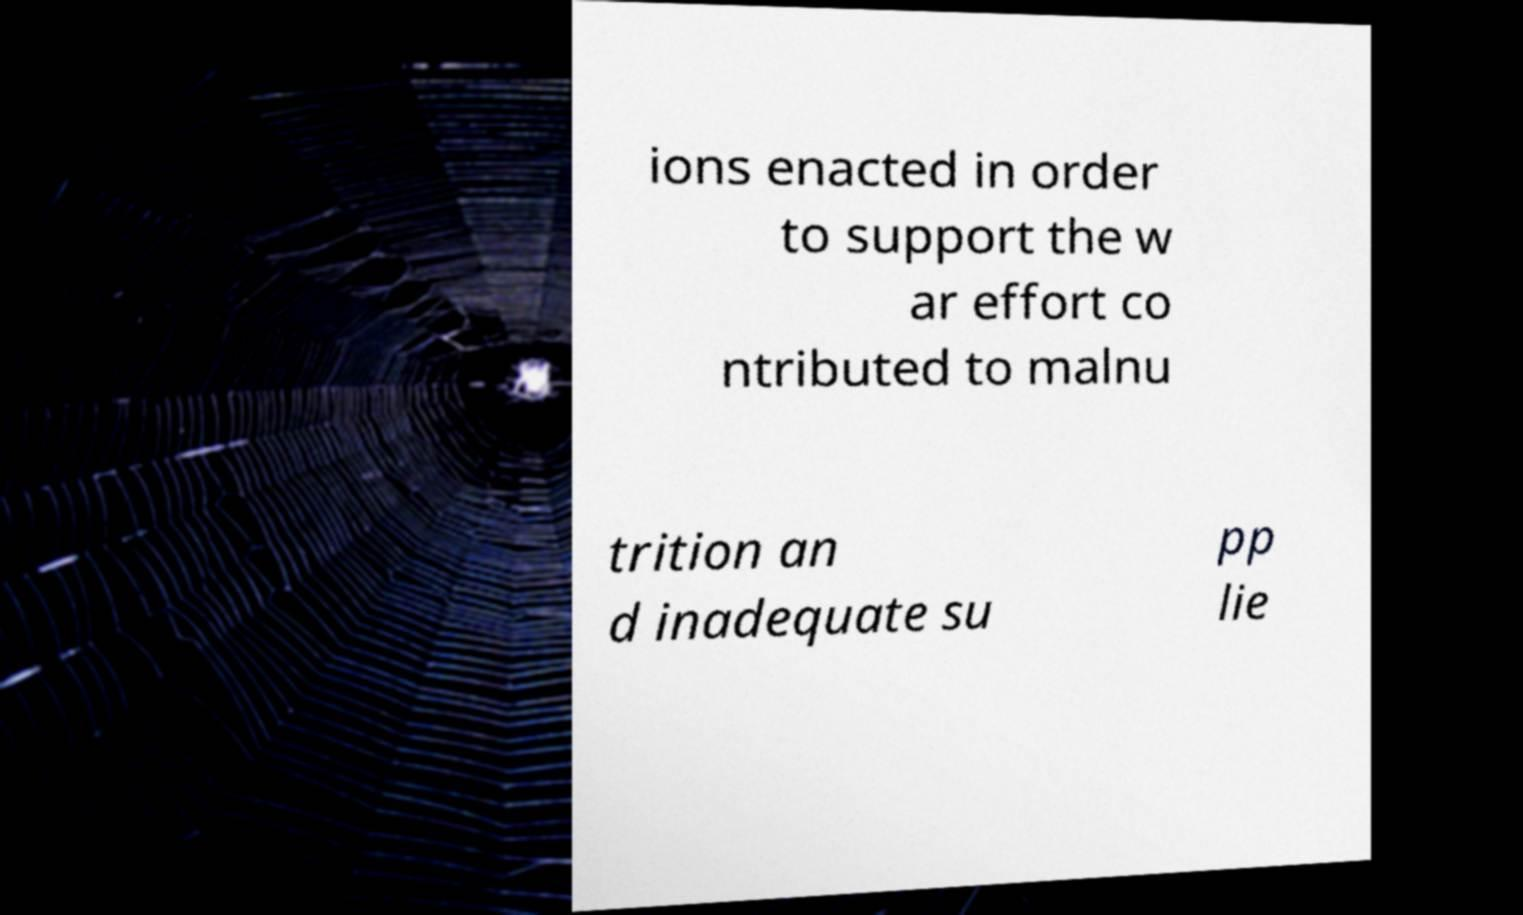Please read and relay the text visible in this image. What does it say? ions enacted in order to support the w ar effort co ntributed to malnu trition an d inadequate su pp lie 